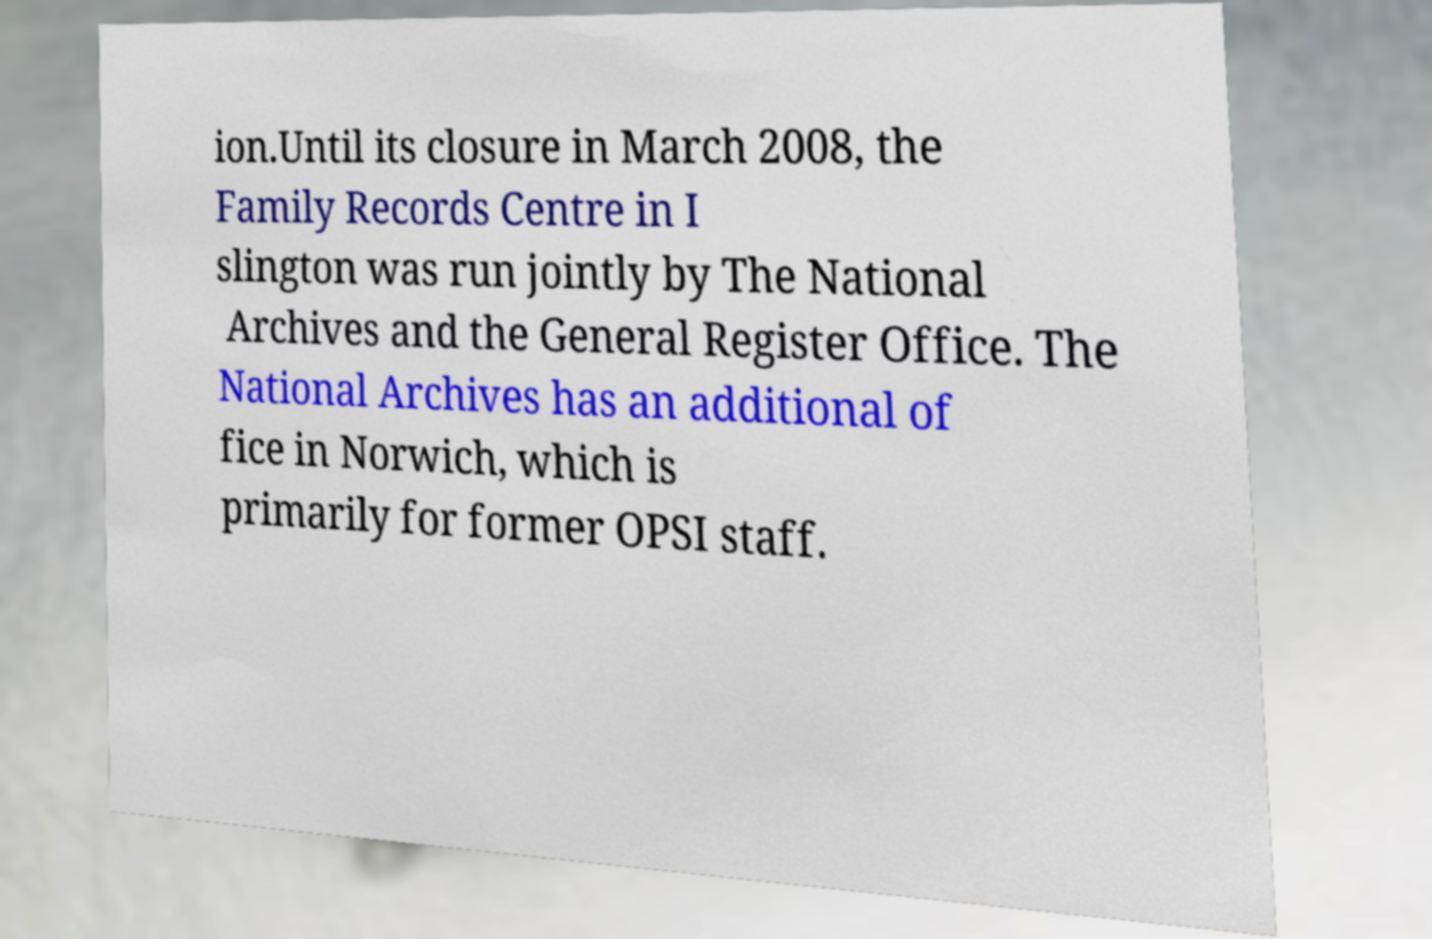Could you extract and type out the text from this image? ion.Until its closure in March 2008, the Family Records Centre in I slington was run jointly by The National Archives and the General Register Office. The National Archives has an additional of fice in Norwich, which is primarily for former OPSI staff. 